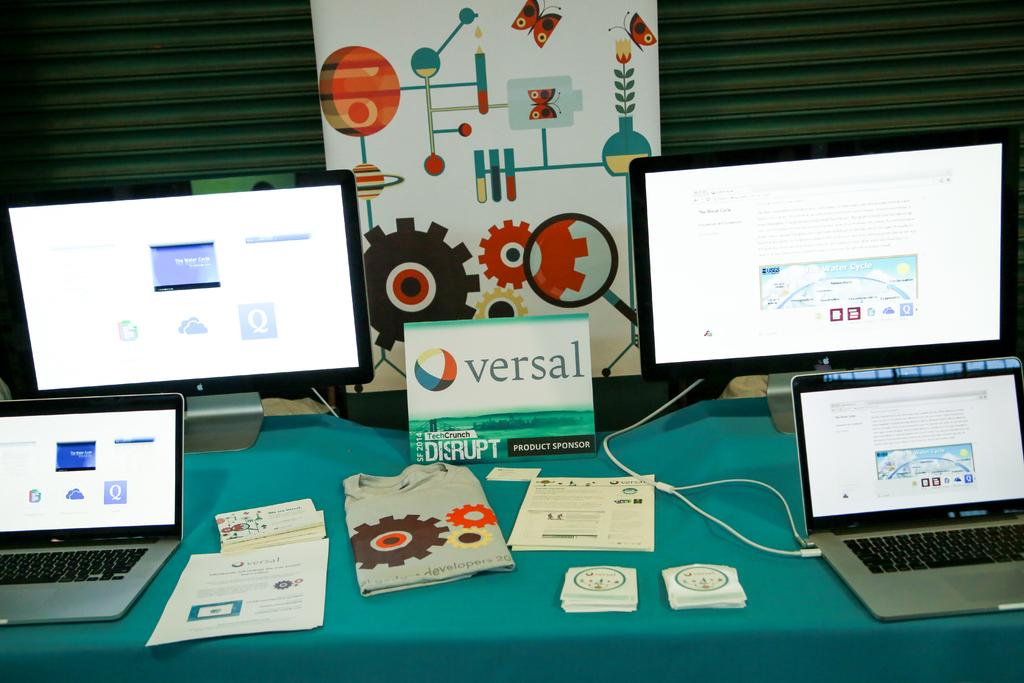<image>
Render a clear and concise summary of the photo. Monitors of various sizes sit on a table with a card that reads Versal in the center. 